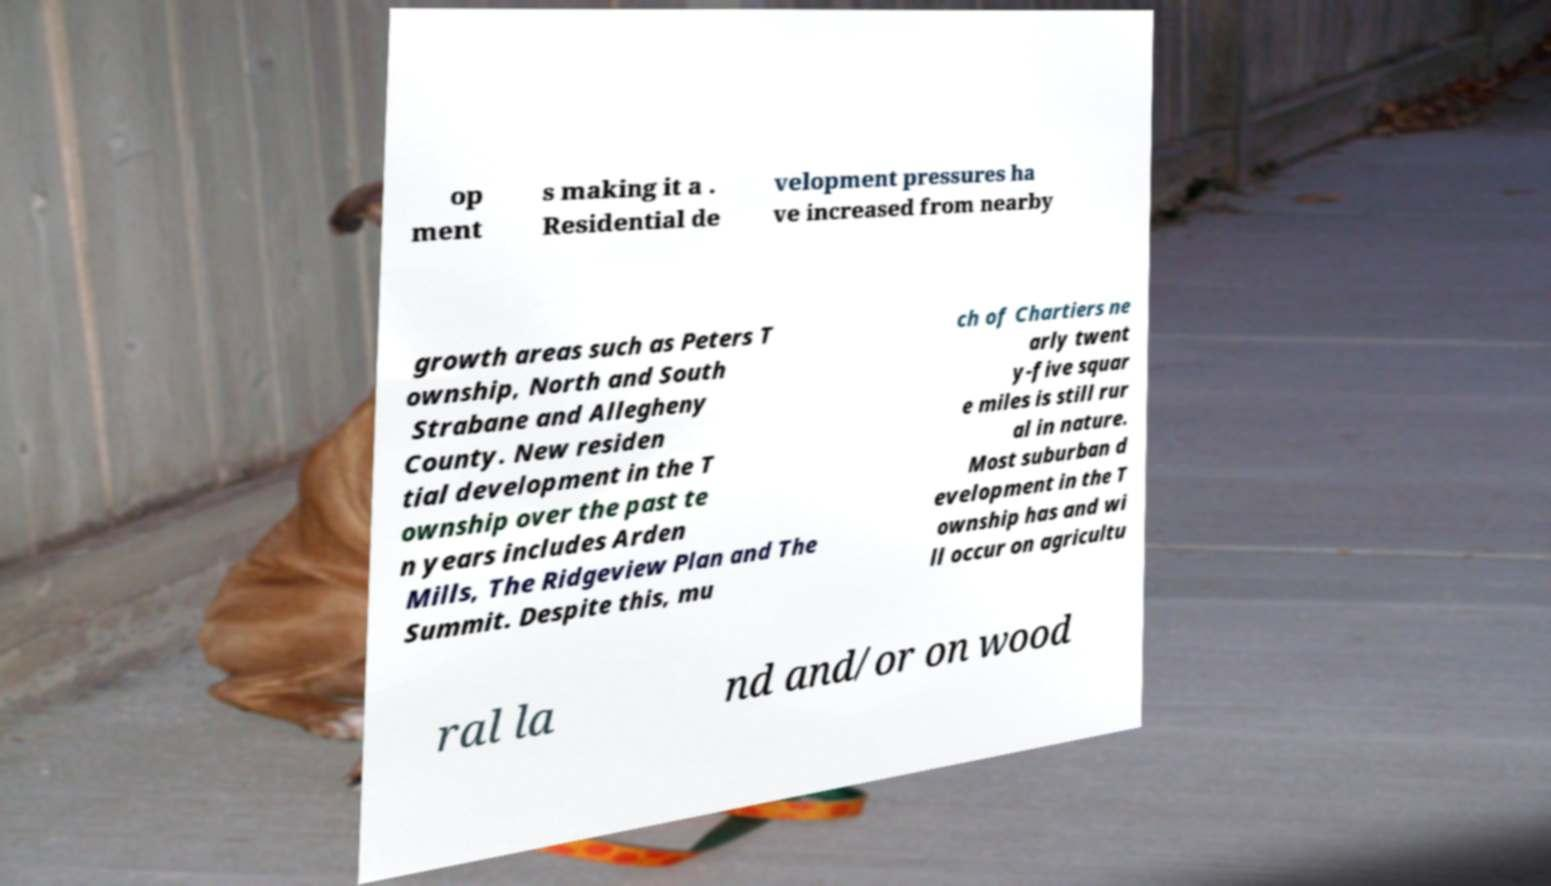Could you extract and type out the text from this image? op ment s making it a . Residential de velopment pressures ha ve increased from nearby growth areas such as Peters T ownship, North and South Strabane and Allegheny County. New residen tial development in the T ownship over the past te n years includes Arden Mills, The Ridgeview Plan and The Summit. Despite this, mu ch of Chartiers ne arly twent y-five squar e miles is still rur al in nature. Most suburban d evelopment in the T ownship has and wi ll occur on agricultu ral la nd and/or on wood 